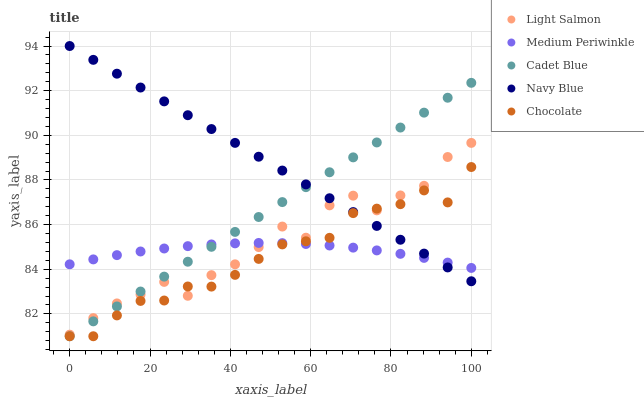Does Chocolate have the minimum area under the curve?
Answer yes or no. Yes. Does Navy Blue have the maximum area under the curve?
Answer yes or no. Yes. Does Light Salmon have the minimum area under the curve?
Answer yes or no. No. Does Light Salmon have the maximum area under the curve?
Answer yes or no. No. Is Navy Blue the smoothest?
Answer yes or no. Yes. Is Light Salmon the roughest?
Answer yes or no. Yes. Is Cadet Blue the smoothest?
Answer yes or no. No. Is Cadet Blue the roughest?
Answer yes or no. No. Does Cadet Blue have the lowest value?
Answer yes or no. Yes. Does Light Salmon have the lowest value?
Answer yes or no. No. Does Navy Blue have the highest value?
Answer yes or no. Yes. Does Light Salmon have the highest value?
Answer yes or no. No. Does Chocolate intersect Medium Periwinkle?
Answer yes or no. Yes. Is Chocolate less than Medium Periwinkle?
Answer yes or no. No. Is Chocolate greater than Medium Periwinkle?
Answer yes or no. No. 